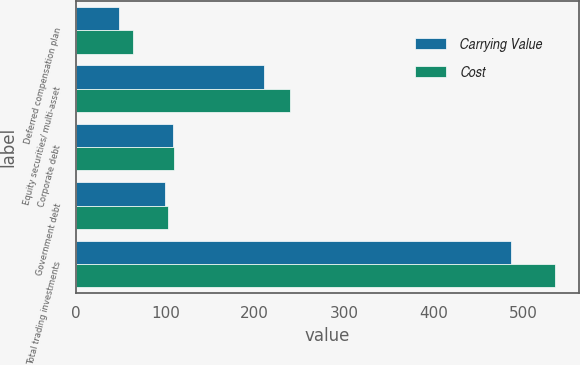Convert chart to OTSL. <chart><loc_0><loc_0><loc_500><loc_500><stacked_bar_chart><ecel><fcel>Deferred compensation plan<fcel>Equity securities/ multi-asset<fcel>Corporate debt<fcel>Government debt<fcel>Total trading investments<nl><fcel>Carrying Value<fcel>48<fcel>210<fcel>109<fcel>100<fcel>487<nl><fcel>Cost<fcel>64<fcel>239<fcel>110<fcel>103<fcel>536<nl></chart> 